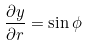<formula> <loc_0><loc_0><loc_500><loc_500>\frac { \partial y } { \partial r } = \sin \phi</formula> 